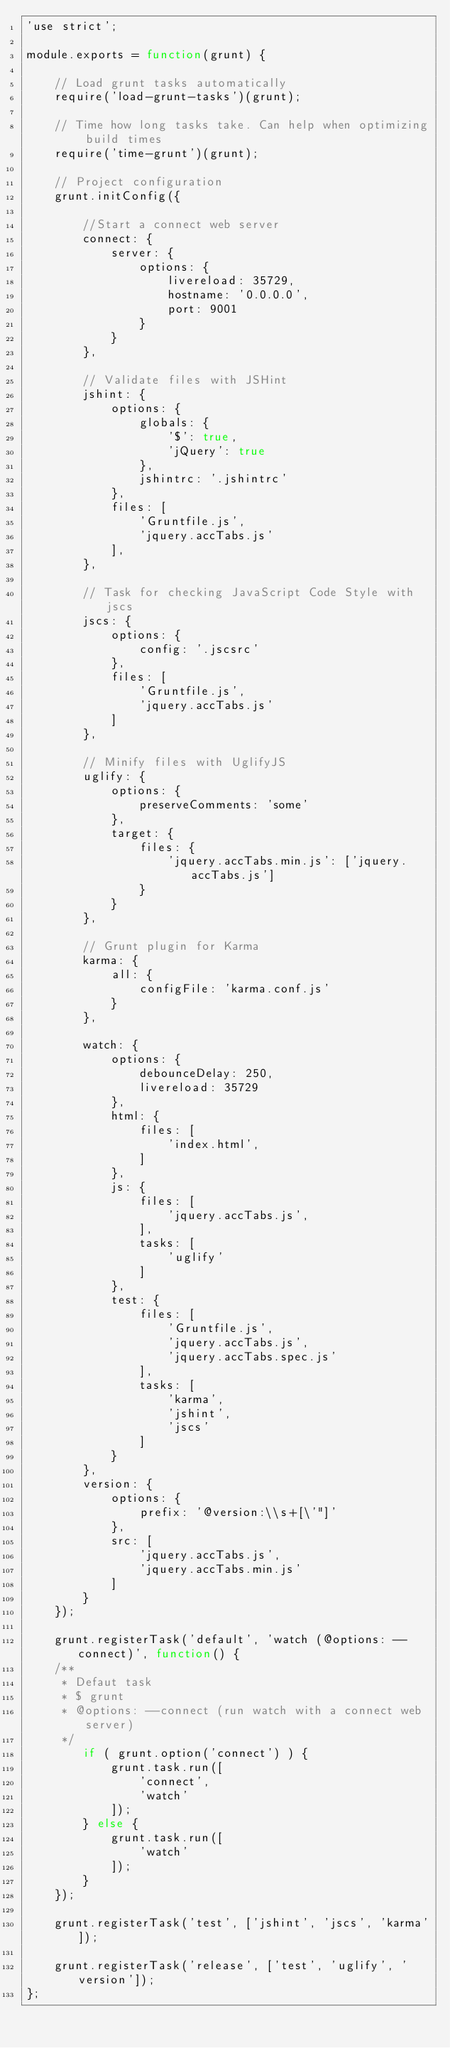<code> <loc_0><loc_0><loc_500><loc_500><_JavaScript_>'use strict';

module.exports = function(grunt) {

    // Load grunt tasks automatically
    require('load-grunt-tasks')(grunt);

    // Time how long tasks take. Can help when optimizing build times
    require('time-grunt')(grunt);

    // Project configuration
    grunt.initConfig({

        //Start a connect web server
        connect: {
            server: {
                options: {
                    livereload: 35729,
                    hostname: '0.0.0.0',
                    port: 9001
                }
            }
        },

        // Validate files with JSHint
        jshint: {
            options: {
                globals: {
                    '$': true,
                    'jQuery': true
                },
                jshintrc: '.jshintrc'
            },
            files: [
                'Gruntfile.js',
                'jquery.accTabs.js'
            ],
        },

        // Task for checking JavaScript Code Style with jscs
        jscs: {
            options: {
                config: '.jscsrc'
            },
            files: [
                'Gruntfile.js',
                'jquery.accTabs.js'
            ]
        },

        // Minify files with UglifyJS
        uglify: {
            options: {
                preserveComments: 'some'
            },
            target: {
                files: {
                    'jquery.accTabs.min.js': ['jquery.accTabs.js']
                }
            }
        },

        // Grunt plugin for Karma
        karma: {
            all: {
                configFile: 'karma.conf.js'
            }
        },

        watch: {
            options: {
                debounceDelay: 250,
                livereload: 35729
            },
            html: {
                files: [
                    'index.html',
                ]
            },
            js: {
                files: [
                    'jquery.accTabs.js',
                ],
                tasks: [
                    'uglify'
                ]
            },
            test: {
                files: [
                    'Gruntfile.js',
                    'jquery.accTabs.js',
                    'jquery.accTabs.spec.js'
                ],
                tasks: [
                    'karma',
                    'jshint',
                    'jscs'
                ]
            }
        },
        version: {
            options: {
                prefix: '@version:\\s+[\'"]'
            },
            src: [
                'jquery.accTabs.js',
                'jquery.accTabs.min.js'
            ]
        }
    });

    grunt.registerTask('default', 'watch (@options: --connect)', function() {
    /**
     * Defaut task
     * $ grunt
     * @options: --connect (run watch with a connect web server)
     */
        if ( grunt.option('connect') ) {
            grunt.task.run([
                'connect',
                'watch'
            ]);
        } else {
            grunt.task.run([
                'watch'
            ]);
        }
    });

    grunt.registerTask('test', ['jshint', 'jscs', 'karma']);

    grunt.registerTask('release', ['test', 'uglify', 'version']);
};</code> 